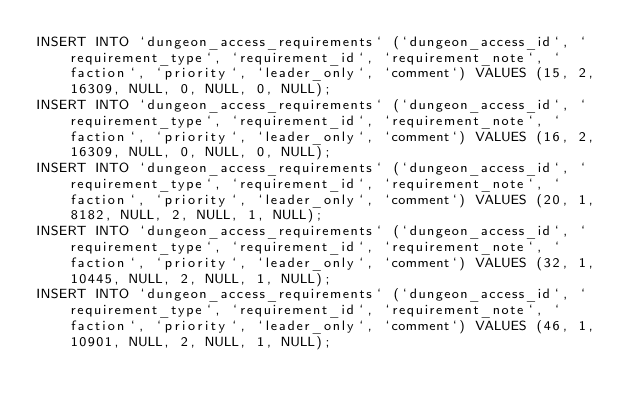<code> <loc_0><loc_0><loc_500><loc_500><_SQL_>INSERT INTO `dungeon_access_requirements` (`dungeon_access_id`, `requirement_type`, `requirement_id`, `requirement_note`, `faction`, `priority`, `leader_only`, `comment`) VALUES (15, 2, 16309, NULL, 0, NULL, 0, NULL);
INSERT INTO `dungeon_access_requirements` (`dungeon_access_id`, `requirement_type`, `requirement_id`, `requirement_note`, `faction`, `priority`, `leader_only`, `comment`) VALUES (16, 2, 16309, NULL, 0, NULL, 0, NULL);
INSERT INTO `dungeon_access_requirements` (`dungeon_access_id`, `requirement_type`, `requirement_id`, `requirement_note`, `faction`, `priority`, `leader_only`, `comment`) VALUES (20, 1, 8182, NULL, 2, NULL, 1, NULL);
INSERT INTO `dungeon_access_requirements` (`dungeon_access_id`, `requirement_type`, `requirement_id`, `requirement_note`, `faction`, `priority`, `leader_only`, `comment`) VALUES (32, 1, 10445, NULL, 2, NULL, 1, NULL);
INSERT INTO `dungeon_access_requirements` (`dungeon_access_id`, `requirement_type`, `requirement_id`, `requirement_note`, `faction`, `priority`, `leader_only`, `comment`) VALUES (46, 1, 10901, NULL, 2, NULL, 1, NULL);</code> 